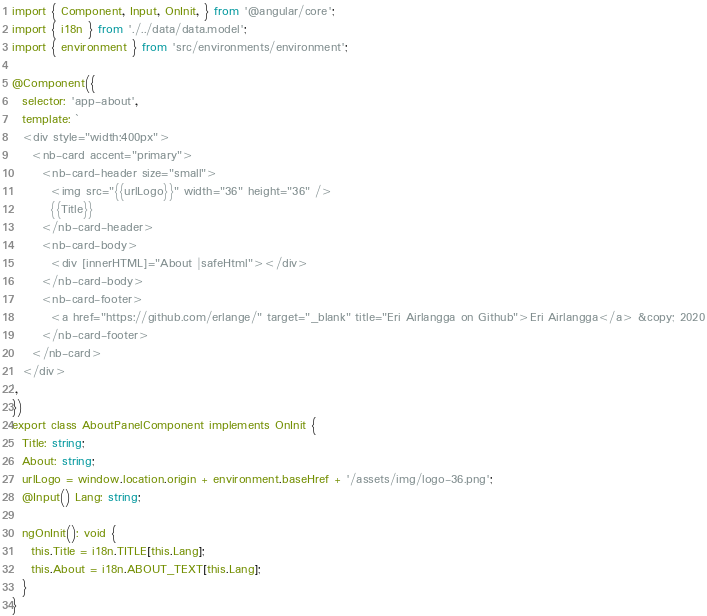<code> <loc_0><loc_0><loc_500><loc_500><_TypeScript_>import { Component, Input, OnInit, } from '@angular/core';
import { i18n } from './../data/data.model';
import { environment } from 'src/environments/environment';

@Component({
  selector: 'app-about',
  template: `
  <div style="width:400px">
    <nb-card accent="primary">
      <nb-card-header size="small">
        <img src="{{urlLogo}}" width="36" height="36" />
        {{Title}}
      </nb-card-header>
      <nb-card-body>
        <div [innerHTML]="About |safeHtml"></div>
      </nb-card-body>
      <nb-card-footer>
        <a href="https://github.com/erlange/" target="_blank" title="Eri Airlangga on Github">Eri Airlangga</a> &copy; 2020
      </nb-card-footer>
    </nb-card>
  </div>
`,
})
export class AboutPanelComponent implements OnInit {
  Title: string;
  About: string;
  urlLogo = window.location.origin + environment.baseHref + '/assets/img/logo-36.png';
  @Input() Lang: string;

  ngOnInit(): void {
    this.Title = i18n.TITLE[this.Lang];
    this.About = i18n.ABOUT_TEXT[this.Lang];
  }
}
</code> 